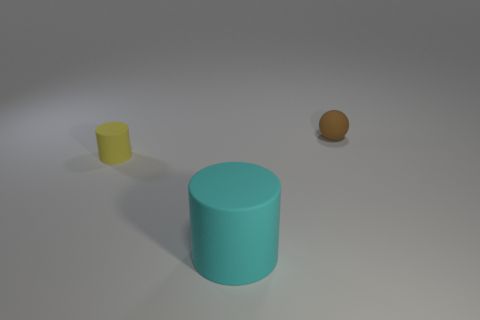Is the matte ball the same color as the large cylinder?
Ensure brevity in your answer.  No. The other thing that is the same shape as the tiny yellow object is what color?
Your response must be concise. Cyan. There is a tiny brown rubber object that is right of the large thing; are there any small brown spheres that are in front of it?
Your response must be concise. No. How many objects are tiny brown matte balls or blue shiny cylinders?
Your answer should be compact. 1. What is the shape of the thing that is both right of the tiny yellow matte object and behind the cyan matte cylinder?
Your answer should be very brief. Sphere. Does the small thing that is to the right of the large cyan thing have the same material as the small yellow thing?
Ensure brevity in your answer.  Yes. How many objects are purple rubber cylinders or objects that are behind the yellow object?
Offer a terse response. 1. What color is the tiny cylinder that is made of the same material as the ball?
Provide a succinct answer. Yellow. What number of cyan objects are made of the same material as the small sphere?
Provide a short and direct response. 1. What number of brown matte objects are there?
Make the answer very short. 1. 